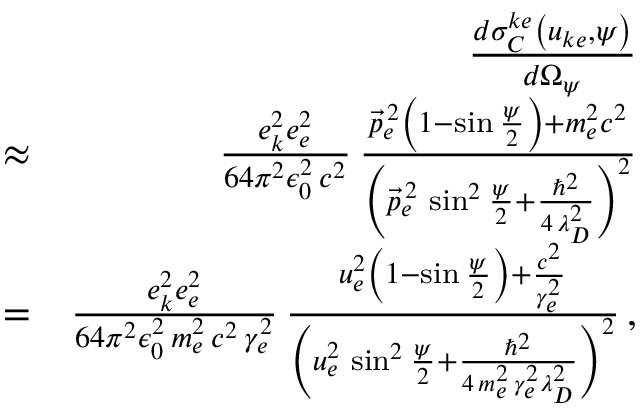<formula> <loc_0><loc_0><loc_500><loc_500>\begin{array} { r l r } & { \frac { d \sigma _ { C } ^ { k e } \left ( u _ { k e } , \psi \right ) } { d \Omega _ { \psi } } } \\ & { \approx } & { \frac { e _ { k } ^ { 2 } e _ { e } ^ { 2 } } { 6 4 \pi ^ { 2 } \epsilon _ { 0 } ^ { 2 } \, c ^ { 2 } } \, \frac { \vec { p } _ { e } ^ { \, 2 } \left ( 1 - \sin \frac { \psi } { 2 } \right ) + m _ { e } ^ { 2 } c ^ { 2 } } { \left ( \vec { p } _ { e } ^ { \, 2 } \, \sin ^ { 2 } \frac { \psi } { 2 } + \frac { \hbar { ^ } { 2 } } { 4 \, \lambda _ { D } ^ { 2 } } \right ) ^ { 2 } } } \\ & { = } & { \frac { e _ { k } ^ { 2 } e _ { e } ^ { 2 } } { 6 4 \pi ^ { 2 } \epsilon _ { 0 } ^ { 2 } \, m _ { e } ^ { 2 } \, c ^ { 2 } \, \gamma _ { e } ^ { 2 } } \, \frac { u _ { e } ^ { 2 } \left ( 1 - \sin \frac { \psi } { 2 } \right ) + \frac { c ^ { 2 } } { \gamma _ { e } ^ { 2 } } } { \left ( u _ { e } ^ { 2 } \, \sin ^ { 2 } \frac { \psi } { 2 } + \frac { \hbar { ^ } { 2 } } { 4 \, m _ { e } ^ { 2 } \, \gamma _ { e } ^ { 2 } \lambda _ { D } ^ { 2 } } \right ) ^ { 2 } } \, , } \end{array}</formula> 